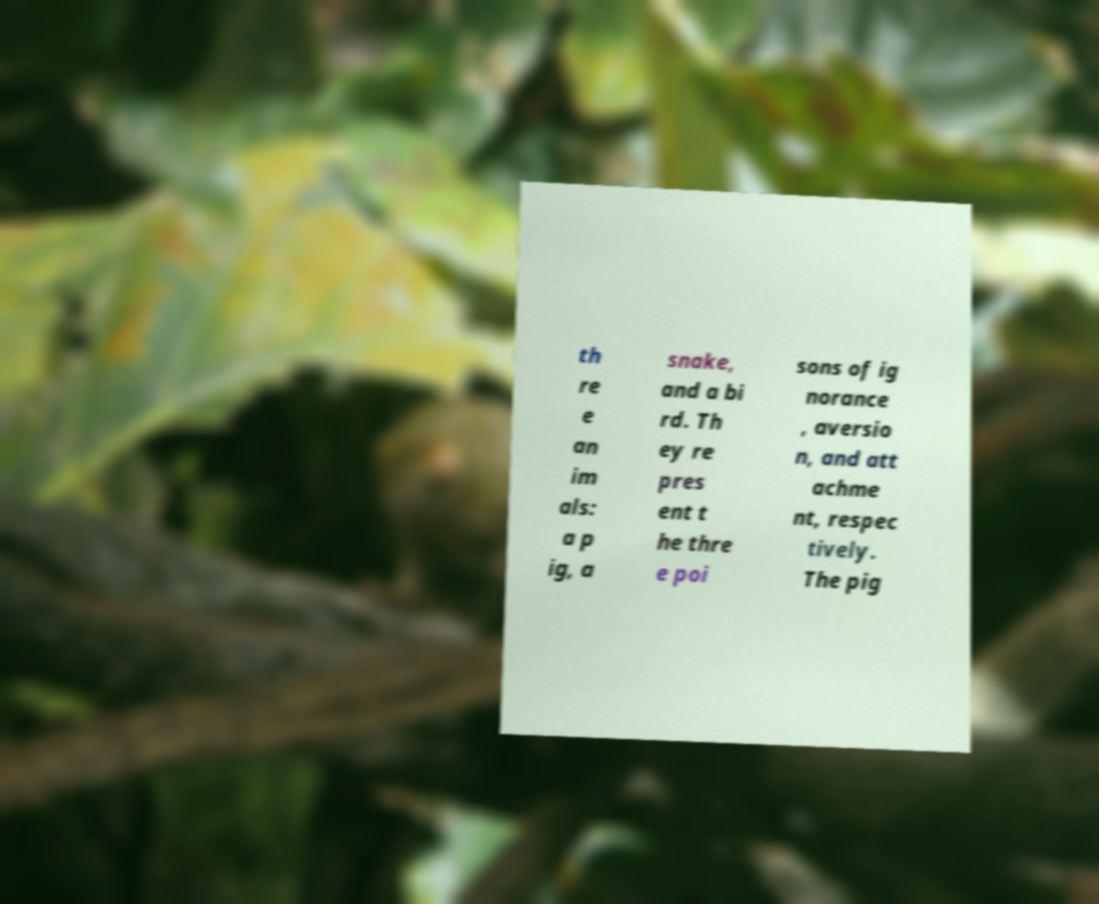Could you assist in decoding the text presented in this image and type it out clearly? th re e an im als: a p ig, a snake, and a bi rd. Th ey re pres ent t he thre e poi sons of ig norance , aversio n, and att achme nt, respec tively. The pig 